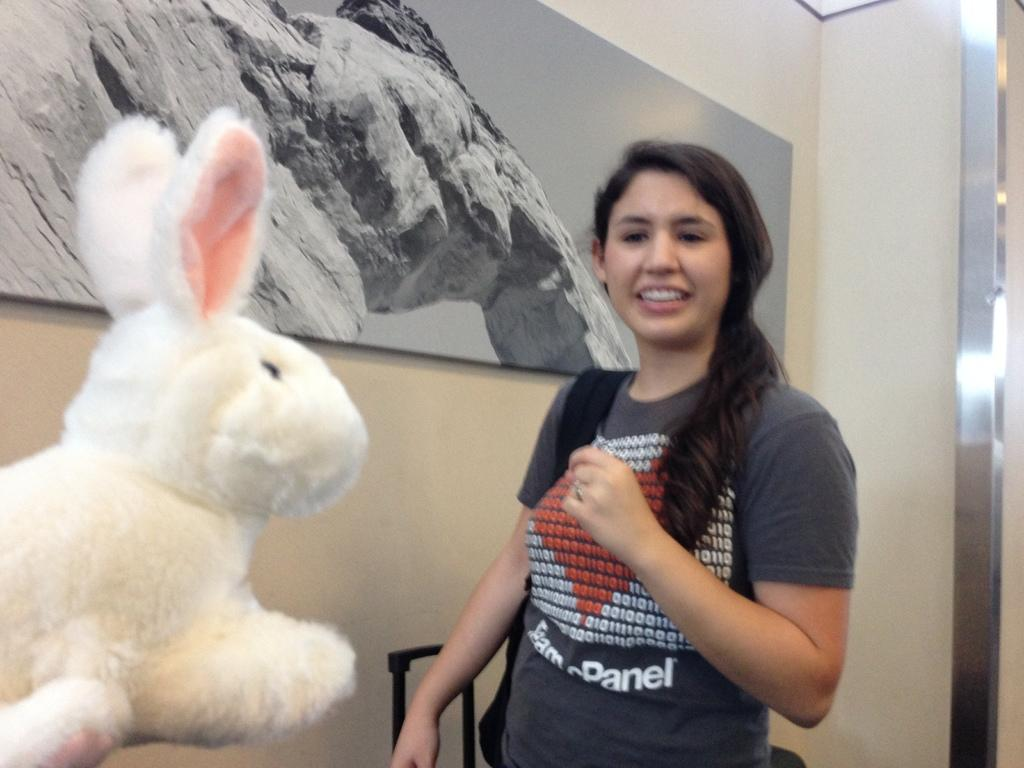Who is present in the image? There is a lady in the image. Where is the lady positioned in the image? The lady is standing on the left side. What type of object can be seen in the image? There is a rabbit toy in the image. What can be seen in the background of the image? There is a wall in the background of the image. What is on the wall in the image? There is a frame on the wall. What is the zephyr discussing with the lady in the image? There is no zephyr present in the image, and therefore no discussion can be observed. What is the lady using to hold the rabbit toy in the image? The lady is not holding the rabbit toy in the image, so there is no mention of an arm or any other body part interacting with the toy. 